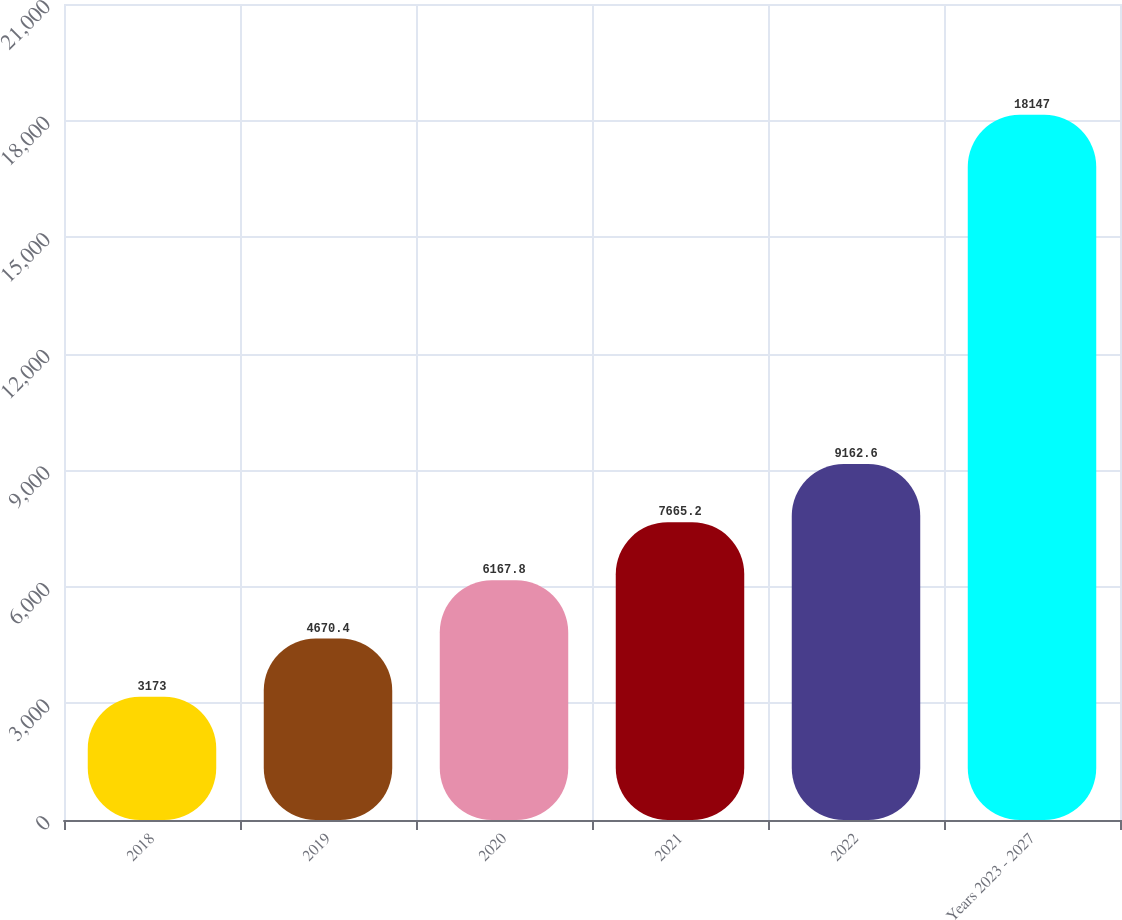Convert chart to OTSL. <chart><loc_0><loc_0><loc_500><loc_500><bar_chart><fcel>2018<fcel>2019<fcel>2020<fcel>2021<fcel>2022<fcel>Years 2023 - 2027<nl><fcel>3173<fcel>4670.4<fcel>6167.8<fcel>7665.2<fcel>9162.6<fcel>18147<nl></chart> 